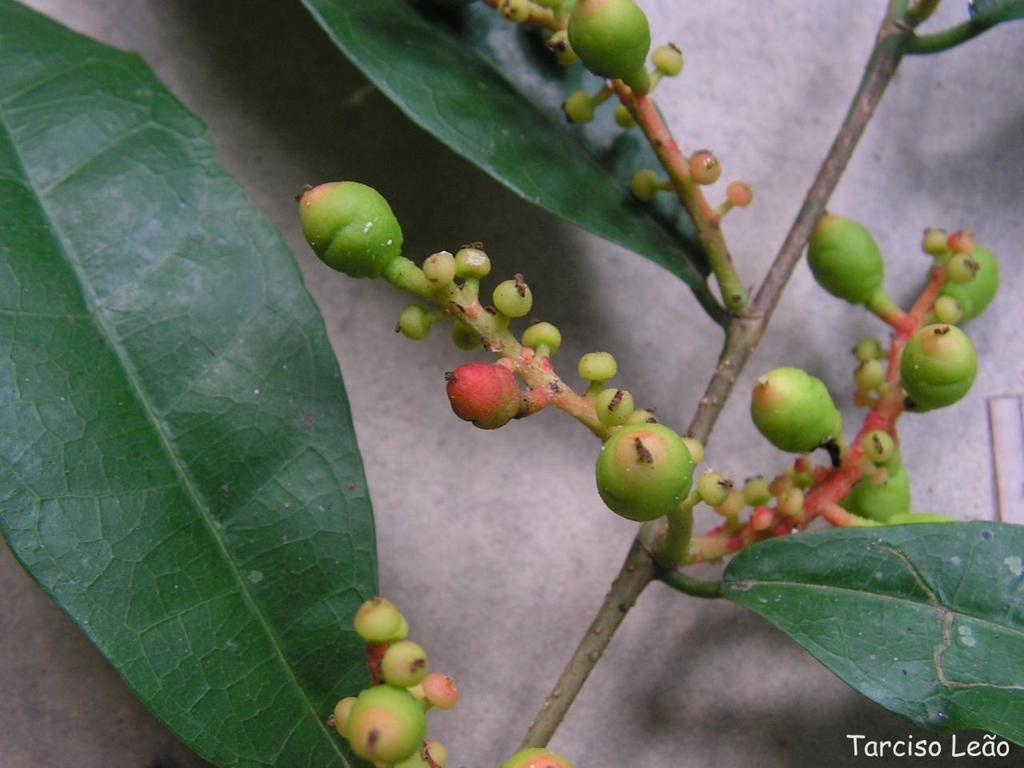What type of living organism is present in the image? There is a plant in the image. What are the main features of the plant? The plant has leaves and green color clusters of figs. What is the background of the image? There is a wall in the image. What year is depicted on the map in the image? There is no map present in the image, so the year cannot be determined. What type of gold object can be seen in the image? There is no gold object present in the image. 